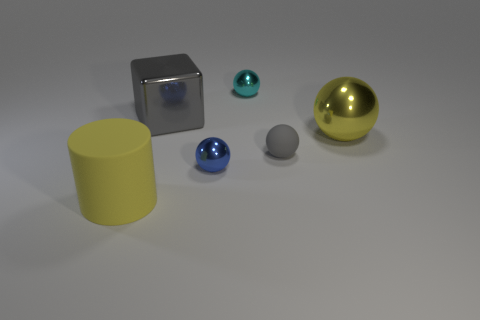Subtract 1 spheres. How many spheres are left? 3 Add 4 matte cylinders. How many objects exist? 10 Subtract all blocks. How many objects are left? 5 Subtract 0 red blocks. How many objects are left? 6 Subtract all blue shiny blocks. Subtract all big gray shiny blocks. How many objects are left? 5 Add 2 big cylinders. How many big cylinders are left? 3 Add 3 small metallic spheres. How many small metallic spheres exist? 5 